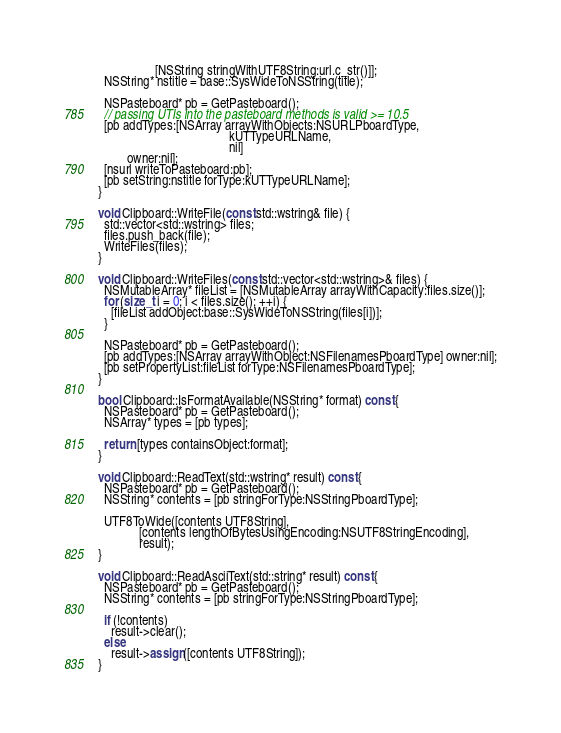<code> <loc_0><loc_0><loc_500><loc_500><_ObjectiveC_>                  [NSString stringWithUTF8String:url.c_str()]];
  NSString* nstitle = base::SysWideToNSString(title);

  NSPasteboard* pb = GetPasteboard();
  // passing UTIs into the pasteboard methods is valid >= 10.5
  [pb addTypes:[NSArray arrayWithObjects:NSURLPboardType,
                                         kUTTypeURLName,
                                         nil]
         owner:nil];
  [nsurl writeToPasteboard:pb];
  [pb setString:nstitle forType:kUTTypeURLName];
}

void Clipboard::WriteFile(const std::wstring& file) {
  std::vector<std::wstring> files;
  files.push_back(file);
  WriteFiles(files);
}

void Clipboard::WriteFiles(const std::vector<std::wstring>& files) {
  NSMutableArray* fileList = [NSMutableArray arrayWithCapacity:files.size()];
  for (size_t i = 0; i < files.size(); ++i) {
    [fileList addObject:base::SysWideToNSString(files[i])];
  }

  NSPasteboard* pb = GetPasteboard();
  [pb addTypes:[NSArray arrayWithObject:NSFilenamesPboardType] owner:nil];
  [pb setPropertyList:fileList forType:NSFilenamesPboardType];
}

bool Clipboard::IsFormatAvailable(NSString* format) const {
  NSPasteboard* pb = GetPasteboard();
  NSArray* types = [pb types];

  return [types containsObject:format];
}

void Clipboard::ReadText(std::wstring* result) const {
  NSPasteboard* pb = GetPasteboard();
  NSString* contents = [pb stringForType:NSStringPboardType];

  UTF8ToWide([contents UTF8String],
             [contents lengthOfBytesUsingEncoding:NSUTF8StringEncoding],
             result);
}

void Clipboard::ReadAsciiText(std::string* result) const {
  NSPasteboard* pb = GetPasteboard();
  NSString* contents = [pb stringForType:NSStringPboardType];

  if (!contents)
    result->clear();
  else
    result->assign([contents UTF8String]);
}
</code> 